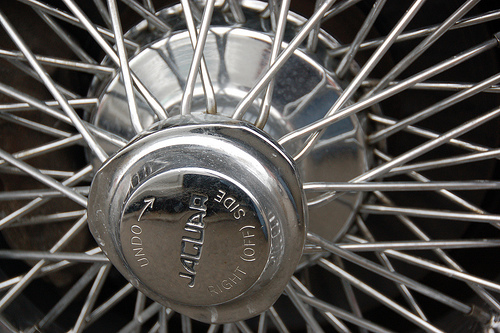<image>
Can you confirm if the spoke is on the wheel? Yes. Looking at the image, I can see the spoke is positioned on top of the wheel, with the wheel providing support. 